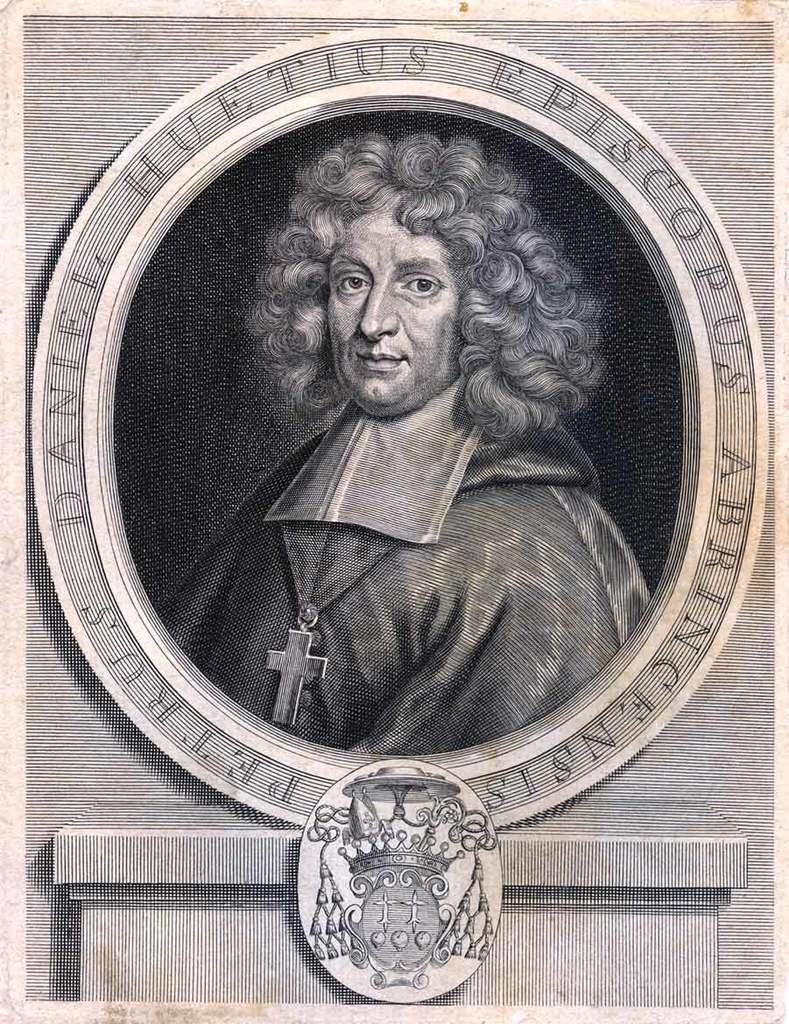In one or two sentences, can you explain what this image depicts? This is the image of the poster where there is a picture of a person, some art and some text. 